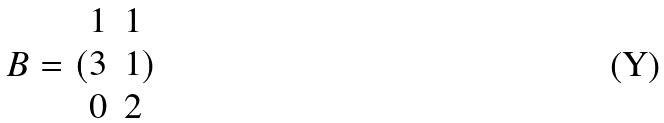<formula> <loc_0><loc_0><loc_500><loc_500>B = ( \begin{matrix} 1 & 1 \\ 3 & 1 \\ 0 & 2 \end{matrix} )</formula> 